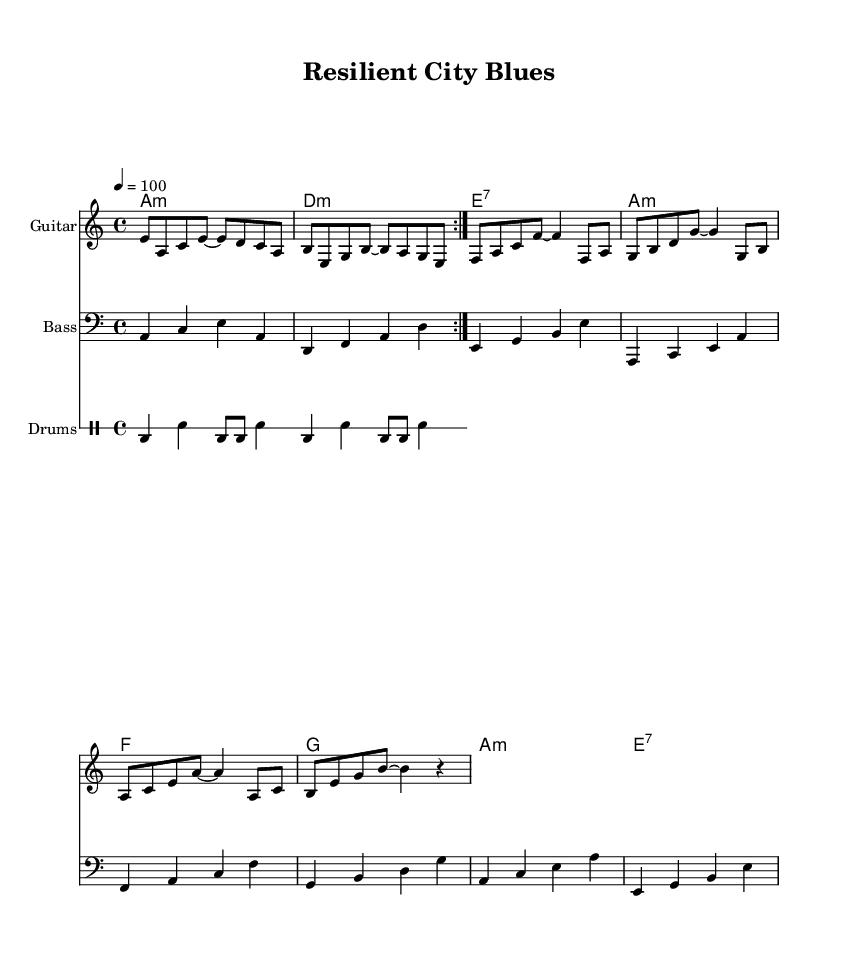What is the key signature of this music? The key signature is A minor, which has no sharps or flats, and is indicated at the beginning of the staff.
Answer: A minor What is the time signature of this music? The time signature is 4/4, which is shown at the beginning of the score. This means there are four beats in each measure, and the quarter note gets one beat.
Answer: 4/4 What is the tempo marking for this piece? The tempo marking is quarter note equals 100, indicating a moderate pace for the performance with beats played at a speed of 100 BPM.
Answer: 100 How many measures are in the guitar section? The guitar section consists of a total of 8 measures, as counted from the repeated volta indication and the distinct patterns that fill the staff.
Answer: 8 What chord is played in the first measure of the guitar part? The first measure features the A minor chord, which is indicated at the beginning of the music as well as by the notes in the measure corresponding to this chord.
Answer: A minor What is the instrument used for the bass part? The bass part is played on a bass guitar, which is specified in the staff header and is indicated by the clef used.
Answer: Bass What type of rhythm pattern is primarily used for the drums? The drum part primarily uses a repeated bass drum and snare drum pattern, characterized by alternating between the two and creating a steady rhythmic feel typical of blues music.
Answer: Bass and snare 